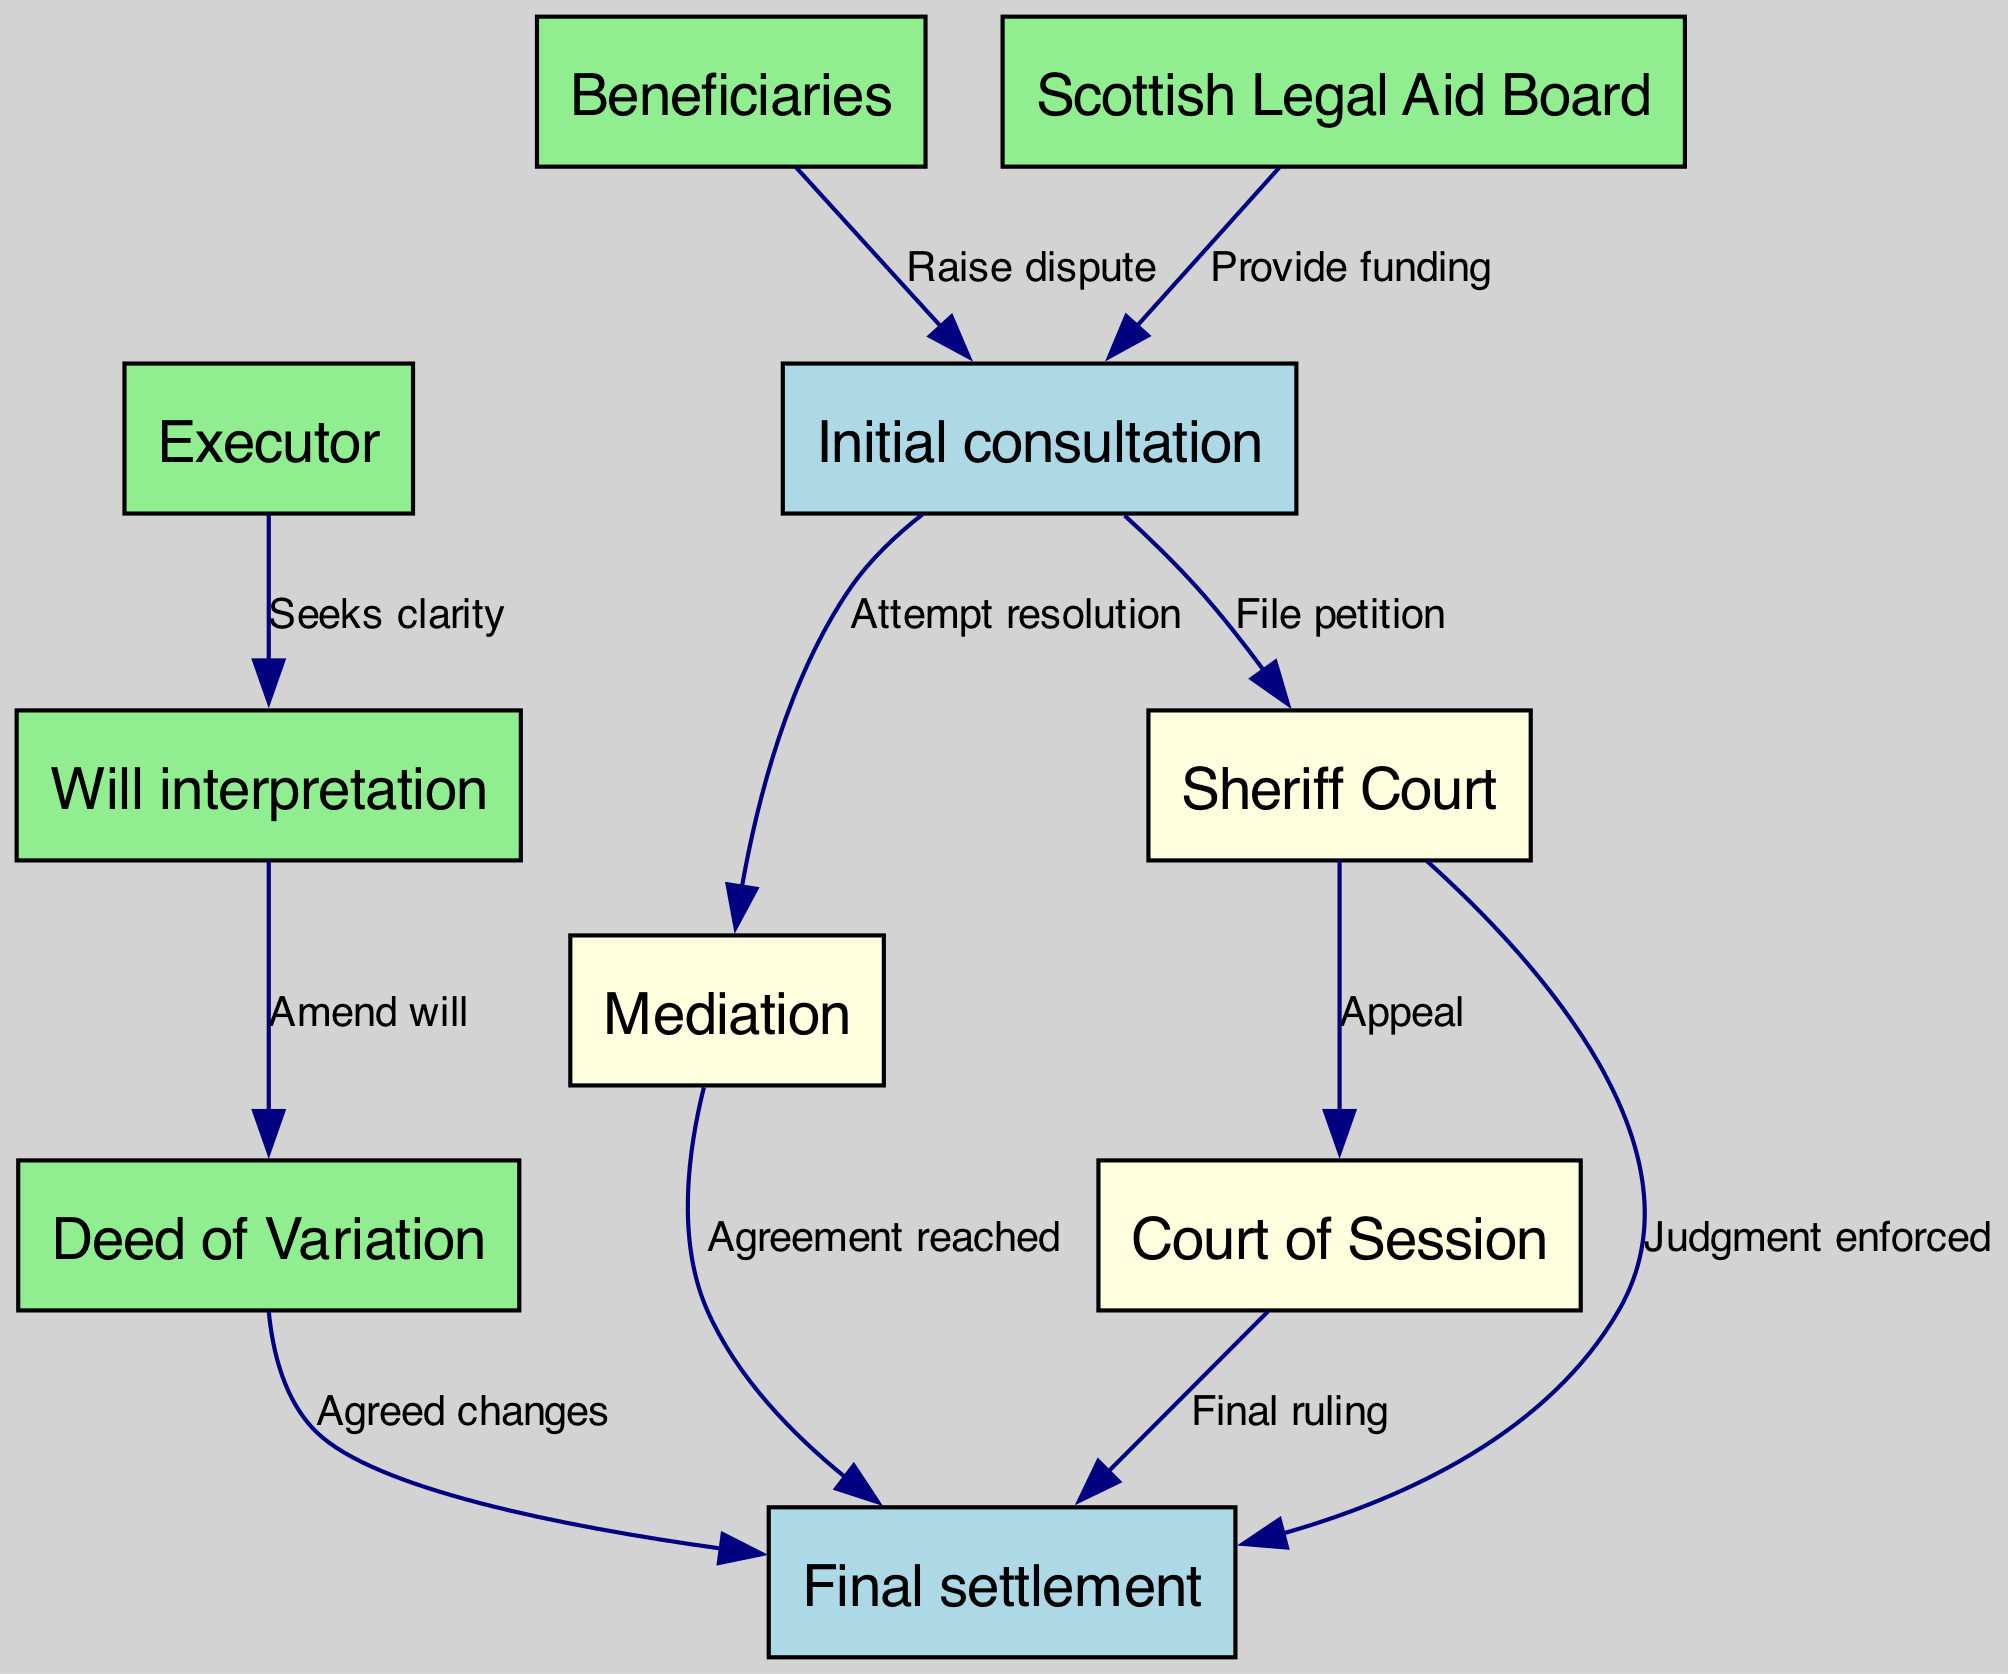What is the first step in the inheritance dispute resolution process? The diagram starts with the 'Initial consultation' node, which represents the first step where parties seek legal advice and discuss the dispute.
Answer: Initial consultation How many nodes are there in the diagram? By counting the nodes listed in the data, there are a total of 10 distinct nodes in the diagram related to the inheritance dispute resolution process.
Answer: 10 Which node leads to 'Final settlement' through 'Mediation'? The flow indicates that 'Mediation' is an intermediary node that directly leads to 'Final settlement' when an agreement is reached.
Answer: Mediation What action can beneficiaries take after the initial consultation? According to the diagram, beneficiaries may 'Raise dispute' after the 'Initial consultation', indicating their intention to contest aspects of the inheritance.
Answer: Raise dispute What is the consequence of a judgment enforced from the 'Sheriff Court'? The 'Sheriff Court' can enforce a 'Final settlement' through a judgment, showing that the court's decision leads to an ending of the dispute.
Answer: Final settlement Which node allows the 'Executor' to seek clarity? The diagram specifies that an 'Executor' can seek clarity through the process of 'Will interpretation', which helps to resolve questions about the will's content.
Answer: Will interpretation What happens if the decision from the 'Sheriff Court' is appealed? The diagram indicates that appealing from the 'Sheriff Court' leads to the 'Court of Session', where the dispute can be further adjudicated or resolved at a higher court level.
Answer: Court of Session What is required for a 'Deed of Variation' to occur? The flow shows that 'Will interpretation' must occur first, leading to a 'Deed of Variation', which suggests that clarity is needed before amending the will.
Answer: Will interpretation How is funding for the initial consultation provided? The 'Scottish Legal Aid Board' provides funding for individuals to access the 'Initial consultation', indicating that financial assistance is available for legal advice.
Answer: Provide funding 